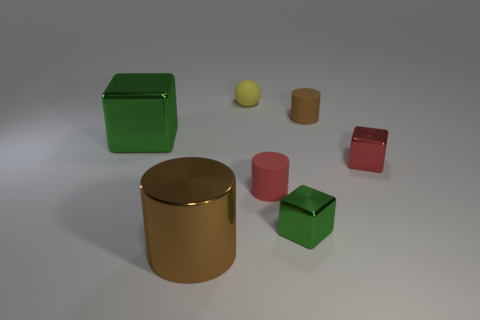There is a red matte thing; are there any rubber objects on the right side of it?
Your answer should be compact. Yes. What material is the brown cylinder that is in front of the rubber cylinder that is in front of the red metal cube?
Make the answer very short. Metal. There is a red rubber object that is the same shape as the large brown metal thing; what size is it?
Keep it short and to the point. Small. Does the large block have the same color as the ball?
Ensure brevity in your answer.  No. There is a thing that is behind the red block and in front of the small brown matte thing; what is its color?
Make the answer very short. Green. There is a object behind the brown rubber cylinder; is its size the same as the red matte thing?
Your answer should be very brief. Yes. Is there anything else that is the same shape as the small yellow thing?
Offer a terse response. No. Does the small green cube have the same material as the brown cylinder that is right of the yellow ball?
Provide a succinct answer. No. What number of green objects are small rubber cylinders or small matte blocks?
Your answer should be compact. 0. Are any tiny yellow matte balls visible?
Your response must be concise. Yes. 